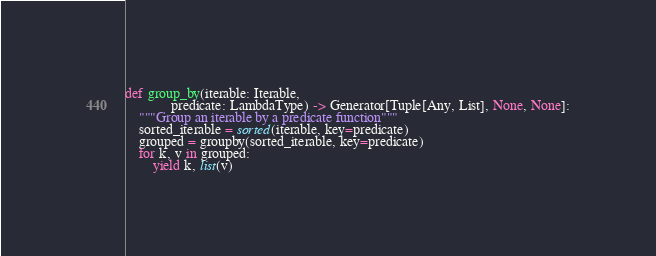<code> <loc_0><loc_0><loc_500><loc_500><_Python_>
def group_by(iterable: Iterable,
             predicate: LambdaType) -> Generator[Tuple[Any, List], None, None]:
    """Group an iterable by a predicate function"""
    sorted_iterable = sorted(iterable, key=predicate)
    grouped = groupby(sorted_iterable, key=predicate)
    for k, v in grouped:
        yield k, list(v)
</code> 